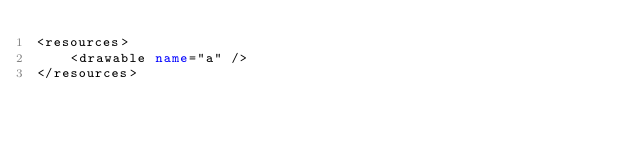Convert code to text. <code><loc_0><loc_0><loc_500><loc_500><_XML_><resources>
    <drawable name="a" />
</resources></code> 